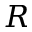<formula> <loc_0><loc_0><loc_500><loc_500>R</formula> 